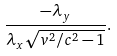<formula> <loc_0><loc_0><loc_500><loc_500>\frac { - \lambda _ { y } } { \lambda _ { x } \sqrt { { v ^ { 2 } / c ^ { 2 } - 1 } } } .</formula> 